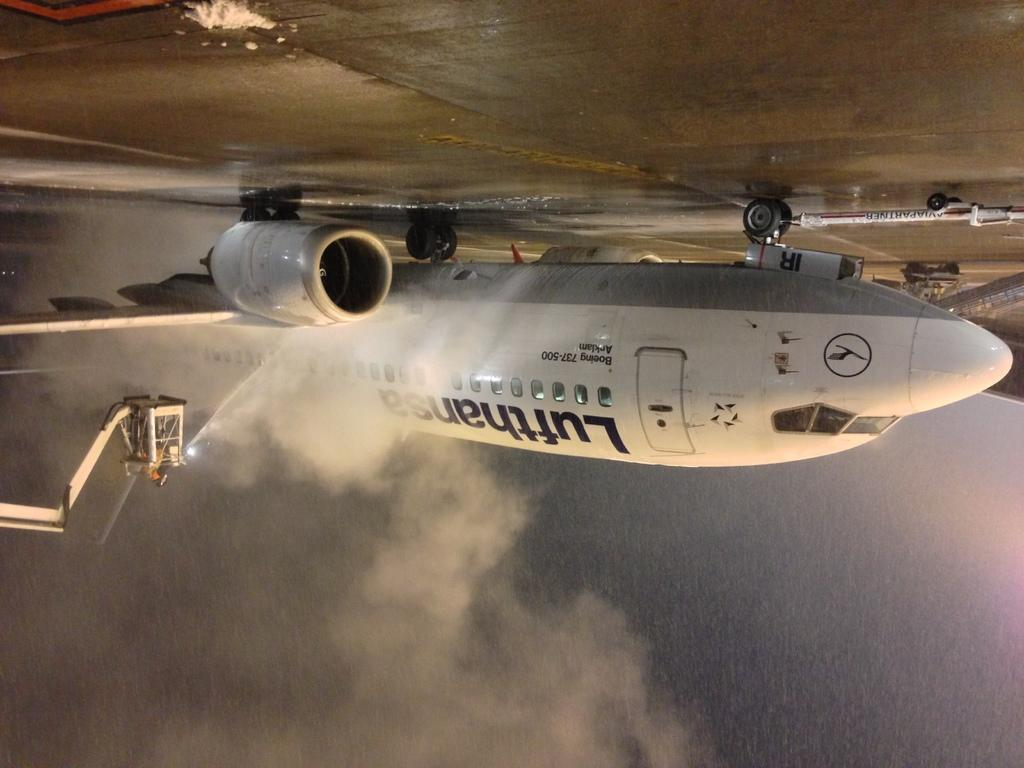Provide a one-sentence caption for the provided image. a photo of an upside down plane with Lufthanser on the side. 